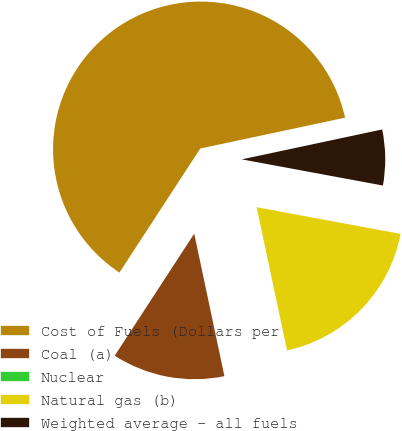Convert chart. <chart><loc_0><loc_0><loc_500><loc_500><pie_chart><fcel>Cost of Fuels (Dollars per<fcel>Coal (a)<fcel>Nuclear<fcel>Natural gas (b)<fcel>Weighted average - all fuels<nl><fcel>62.47%<fcel>12.51%<fcel>0.01%<fcel>18.75%<fcel>6.26%<nl></chart> 